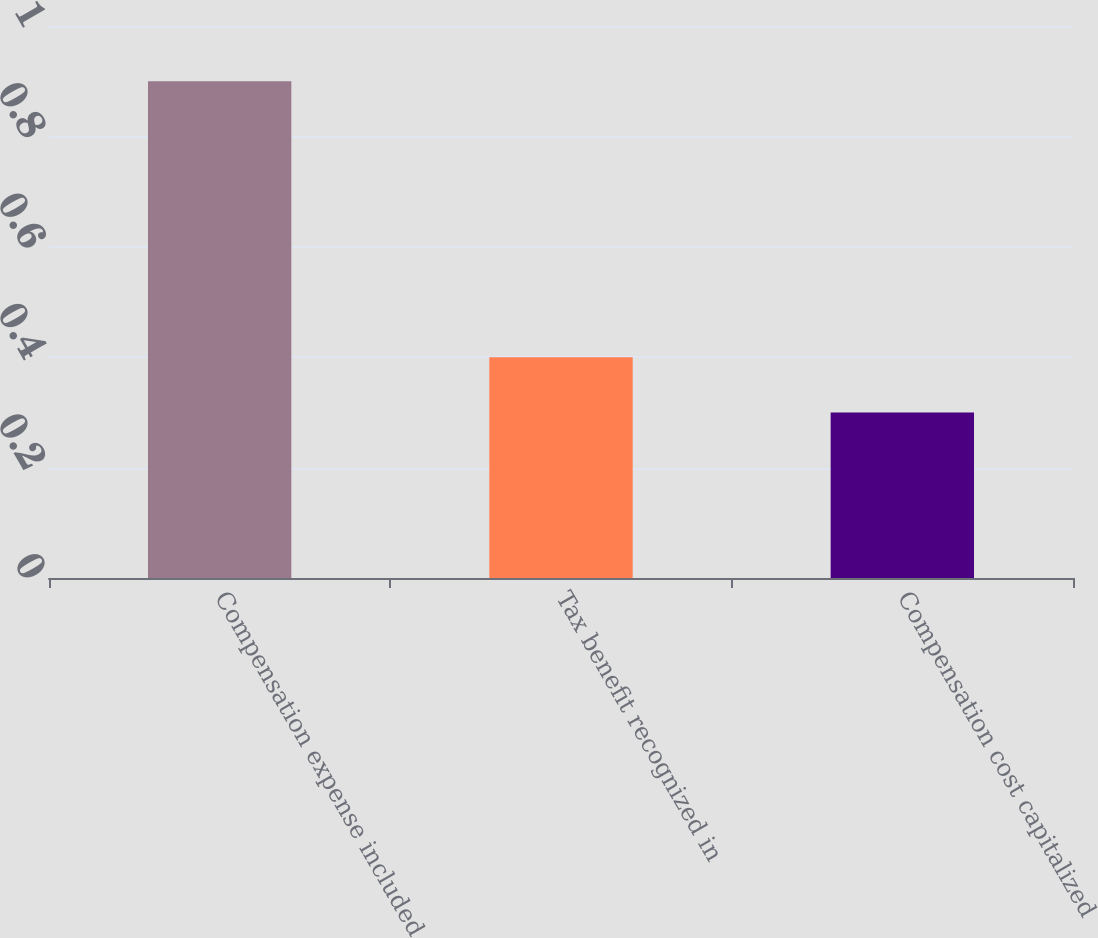Convert chart to OTSL. <chart><loc_0><loc_0><loc_500><loc_500><bar_chart><fcel>Compensation expense included<fcel>Tax benefit recognized in<fcel>Compensation cost capitalized<nl><fcel>0.9<fcel>0.4<fcel>0.3<nl></chart> 